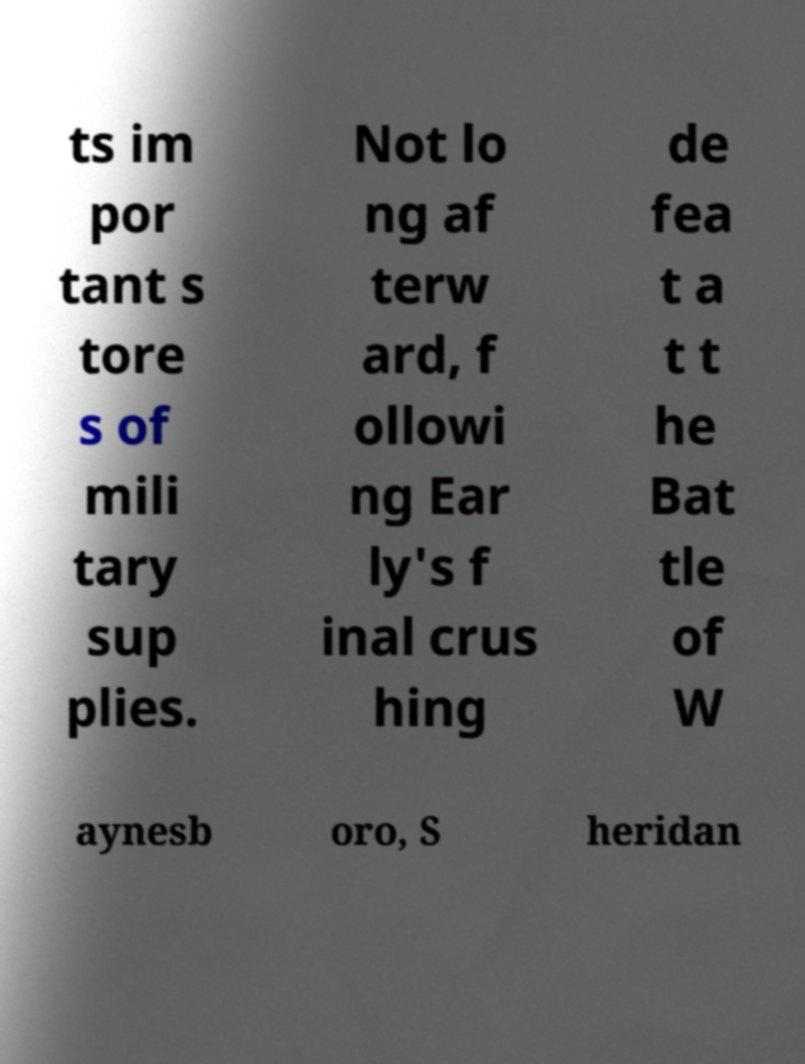There's text embedded in this image that I need extracted. Can you transcribe it verbatim? ts im por tant s tore s of mili tary sup plies. Not lo ng af terw ard, f ollowi ng Ear ly's f inal crus hing de fea t a t t he Bat tle of W aynesb oro, S heridan 